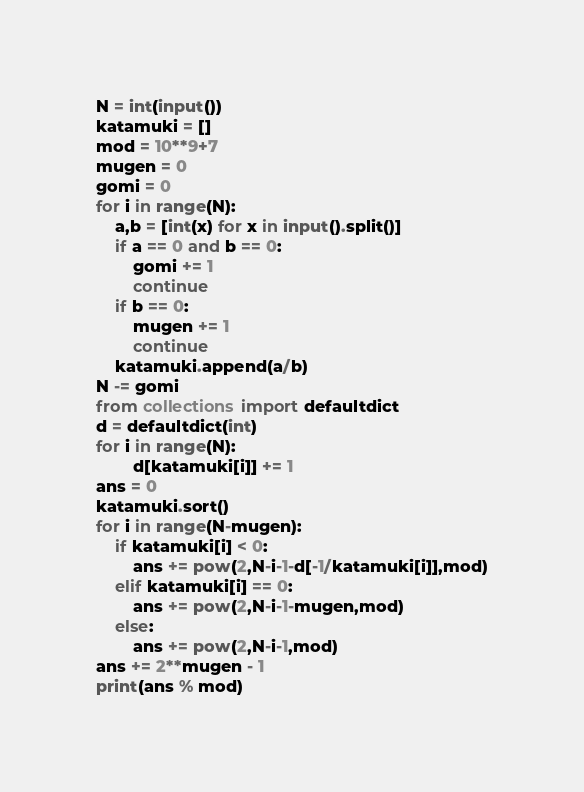Convert code to text. <code><loc_0><loc_0><loc_500><loc_500><_Python_>N = int(input())
katamuki = []
mod = 10**9+7
mugen = 0
gomi = 0
for i in range(N):
    a,b = [int(x) for x in input().split()]
    if a == 0 and b == 0:
        gomi += 1
        continue
    if b == 0:
        mugen += 1
        continue
    katamuki.append(a/b)
N -= gomi
from collections import defaultdict
d = defaultdict(int)
for i in range(N):
        d[katamuki[i]] += 1
ans = 0
katamuki.sort()
for i in range(N-mugen):
    if katamuki[i] < 0:
        ans += pow(2,N-i-1-d[-1/katamuki[i]],mod)
    elif katamuki[i] == 0:
        ans += pow(2,N-i-1-mugen,mod)
    else:
        ans += pow(2,N-i-1,mod)
ans += 2**mugen - 1
print(ans % mod)</code> 